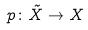<formula> <loc_0><loc_0><loc_500><loc_500>p \colon \tilde { X } \rightarrow X</formula> 